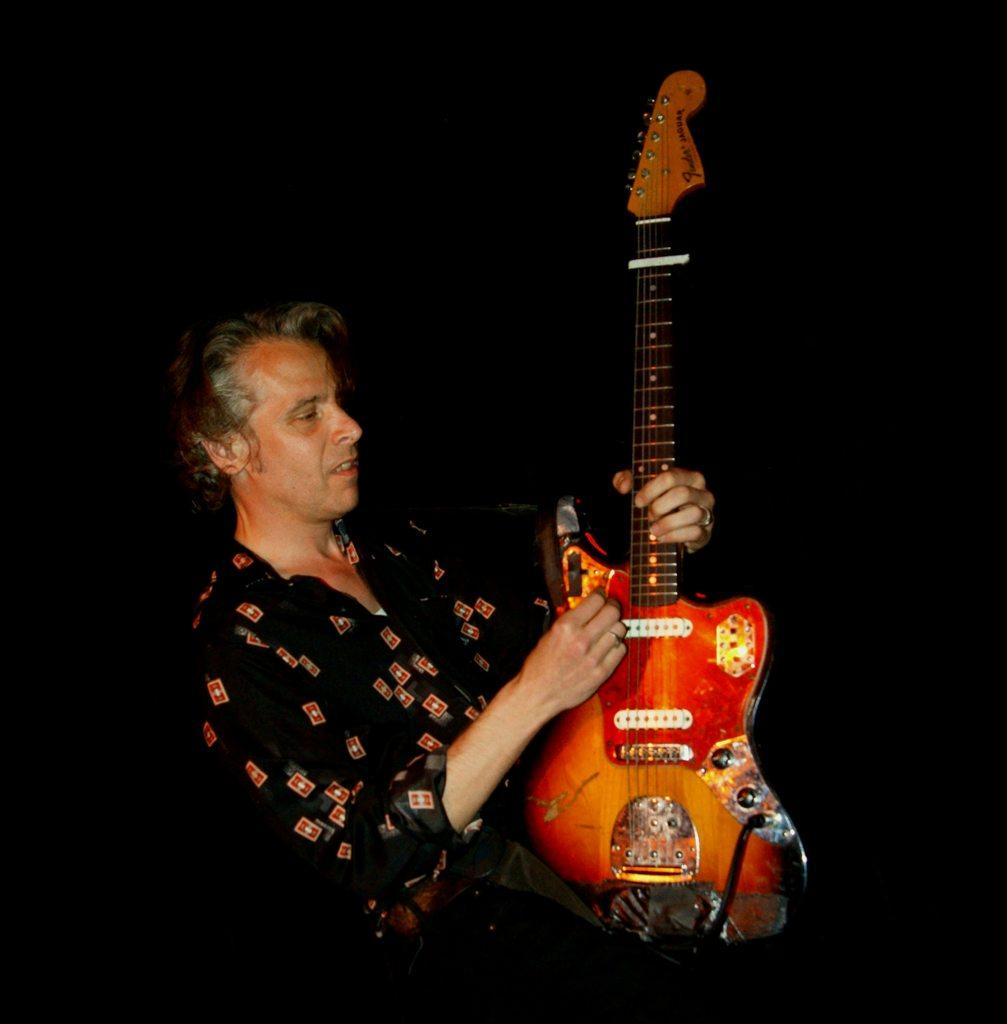What is the main subject of the image? The main subject of the image is a man. What is the man holding in the image? The man is holding a guitar. Where is the hen located in the image? There is no hen present in the image. What type of lunch is being prepared in the image? There is no lunch preparation visible in the image. 